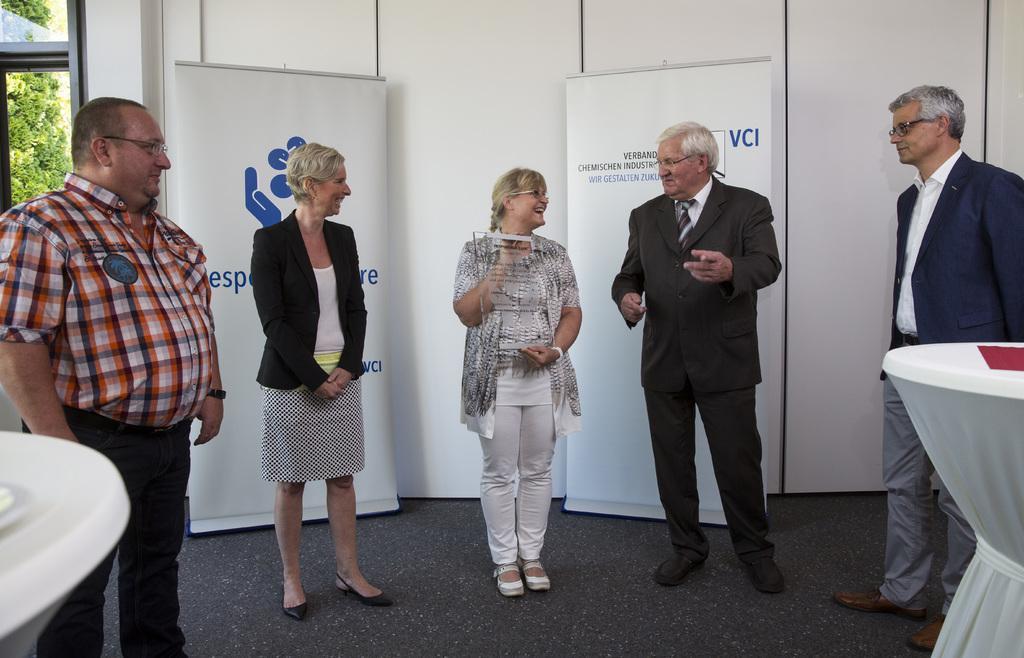In one or two sentences, can you explain what this image depicts? In this image there are people standing on the floor. Behind them there are banners. In the background of the image there is a wall. Beside the wall there is a glass window through which we can see trees. On the right side of the image there is a table. 